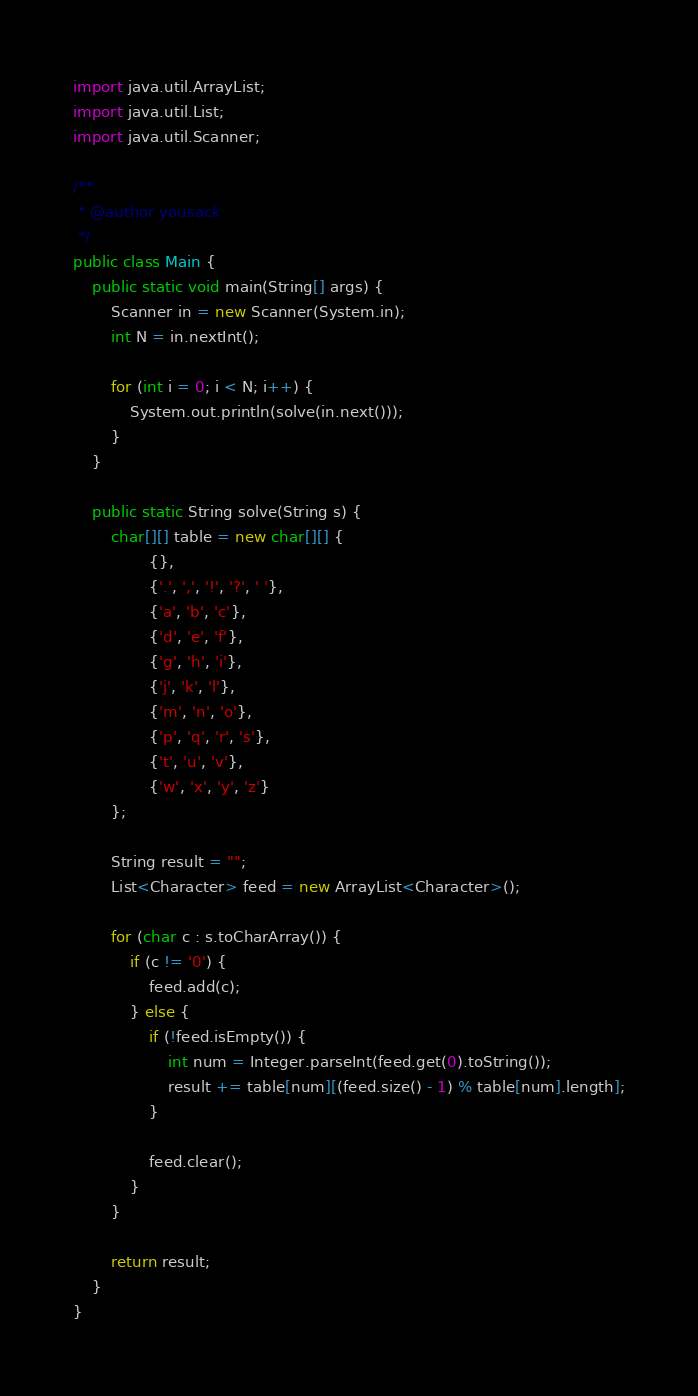Convert code to text. <code><loc_0><loc_0><loc_500><loc_500><_Java_>import java.util.ArrayList;
import java.util.List;
import java.util.Scanner;

/**
 * @author yousack
 */
public class Main {
    public static void main(String[] args) {
        Scanner in = new Scanner(System.in);
        int N = in.nextInt();

        for (int i = 0; i < N; i++) {
            System.out.println(solve(in.next()));
        }
    }
    
    public static String solve(String s) {
        char[][] table = new char[][] {
                {},
                {'.', ',', '!', '?', ' '},
                {'a', 'b', 'c'},
                {'d', 'e', 'f'},
                {'g', 'h', 'i'},
                {'j', 'k', 'l'},
                {'m', 'n', 'o'},
                {'p', 'q', 'r', 's'},
                {'t', 'u', 'v'},
                {'w', 'x', 'y', 'z'}
        };
        
        String result = "";
        List<Character> feed = new ArrayList<Character>();
        
        for (char c : s.toCharArray()) {
            if (c != '0') {
                feed.add(c);
            } else {
                if (!feed.isEmpty()) {
                    int num = Integer.parseInt(feed.get(0).toString());
                    result += table[num][(feed.size() - 1) % table[num].length];
                }
                
                feed.clear();
            }
        }
        
        return result;
    }
}</code> 